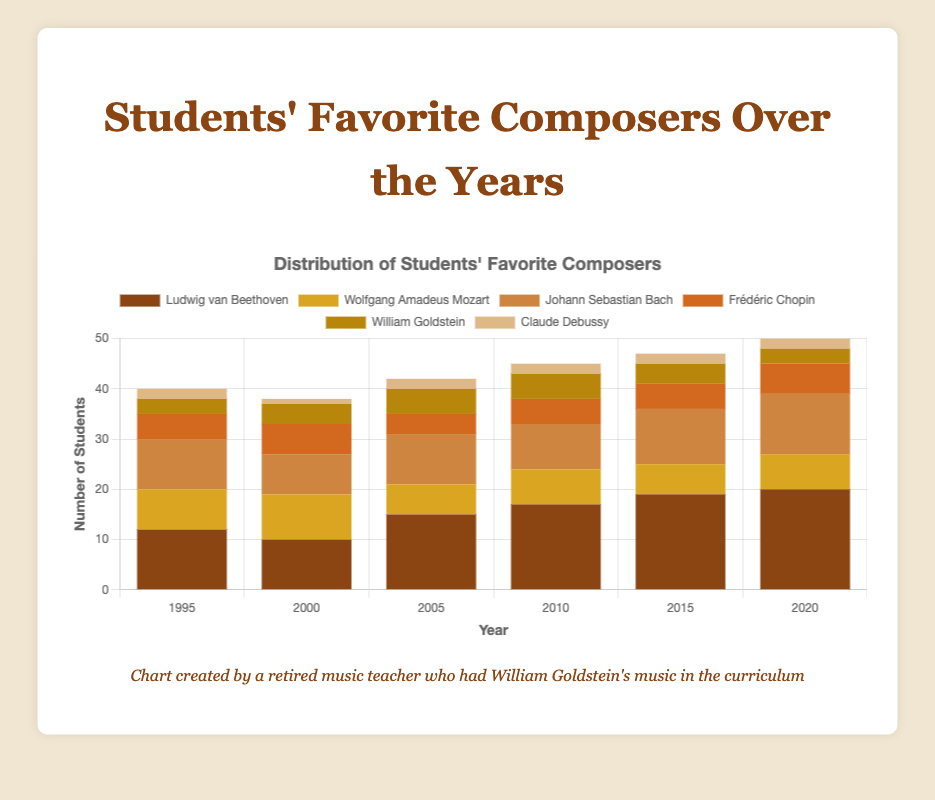Which year had the highest number of students favoring Ludwig van Beethoven? By observing the height of the Ludwig van Beethoven segments in each stacked bar, it is evident that the year 2020 had the highest segment, indicating the highest number of students favoring Beethoven in that year.
Answer: 2020 Which composer had a consistent number of students each year? William Goldstein had slight fluctuations in the number of favored students throughout the years, but Claude Debussy consistently had 2 students in favor each year except for 2000.
Answer: Claude Debussy What's the sum of students favoring Frédéric Chopin in 1995 and 2010? From the figure, in 1995, 5 students favored Frédéric Chopin, and in 2010, 5 students favored him. Summing these gives 5 + 5.
Answer: 10 Which year had the least students favoring Wolfgang Amadeus Mozart? The segment heights for Wolfgang Amadeus Mozart (depicted in gold color) are lowest in 2015 among all years.
Answer: 2015 Compare the number of students favoring Johann Sebastian Bach in 2000 and 2020. Which year had more? By comparing the heights of the segments representing Johann Sebastian Bach (depicted in brown color) in 2000 and 2020, 2020 had a higher segment, meaning more students favored him in that year.
Answer: 2020 If you sum the number of students favoring Ludwig van Beethoven, Johann Sebastian Bach, and William Goldstein in 2015, what total do you get? For 2015: 
- Ludwig van Beethoven: 19 students
- Johann Sebastian Bach: 11 students
- William Goldstein: 4 students.
Summing these: 19 + 11 + 4 gives 34 students.
Answer: 34 In which year did William Goldstein have the highest number of students who favored him? By observing the height of the segments for William Goldstein (depicted in ochre color) across the years, the highest segment appears in 2005.
Answer: 2005 How did the total number of students favoring Claude Debussy change from 1995 to 2020? Claude Debussy had 2 students in 1995 and 2 students in 2020. The total number of students favoring him remained constant over these years.
Answer: No change What's the increase in students favoring Ludwig van Beethoven from 1995 to 2020? In 1995, 12 students favored Beethoven, and in 2020, this number increased to 20. The increase is 20 - 12.
Answer: 8 Compare the number of students favoring Wolfgang Amadeus Mozart and Frédéric Chopin in 1995. Which composer had more students? By comparing the segment heights, Wolfgang Amadeus Mozart had 8 students, and Frédéric Chopin had 5 students in 1995. Thus, more students favored Mozart.
Answer: Wolfgang Amadeus Mozart 